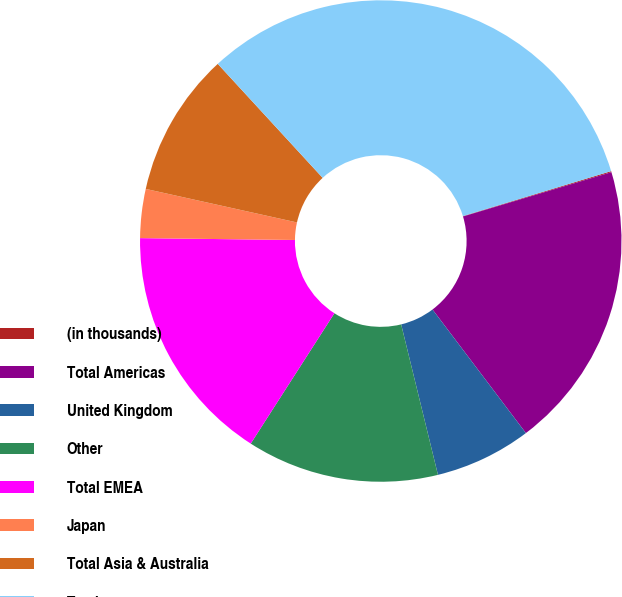Convert chart to OTSL. <chart><loc_0><loc_0><loc_500><loc_500><pie_chart><fcel>(in thousands)<fcel>Total Americas<fcel>United Kingdom<fcel>Other<fcel>Total EMEA<fcel>Japan<fcel>Total Asia & Australia<fcel>Total<nl><fcel>0.07%<fcel>19.32%<fcel>6.48%<fcel>12.9%<fcel>16.11%<fcel>3.28%<fcel>9.69%<fcel>32.15%<nl></chart> 